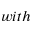<formula> <loc_0><loc_0><loc_500><loc_500>w i t h</formula> 